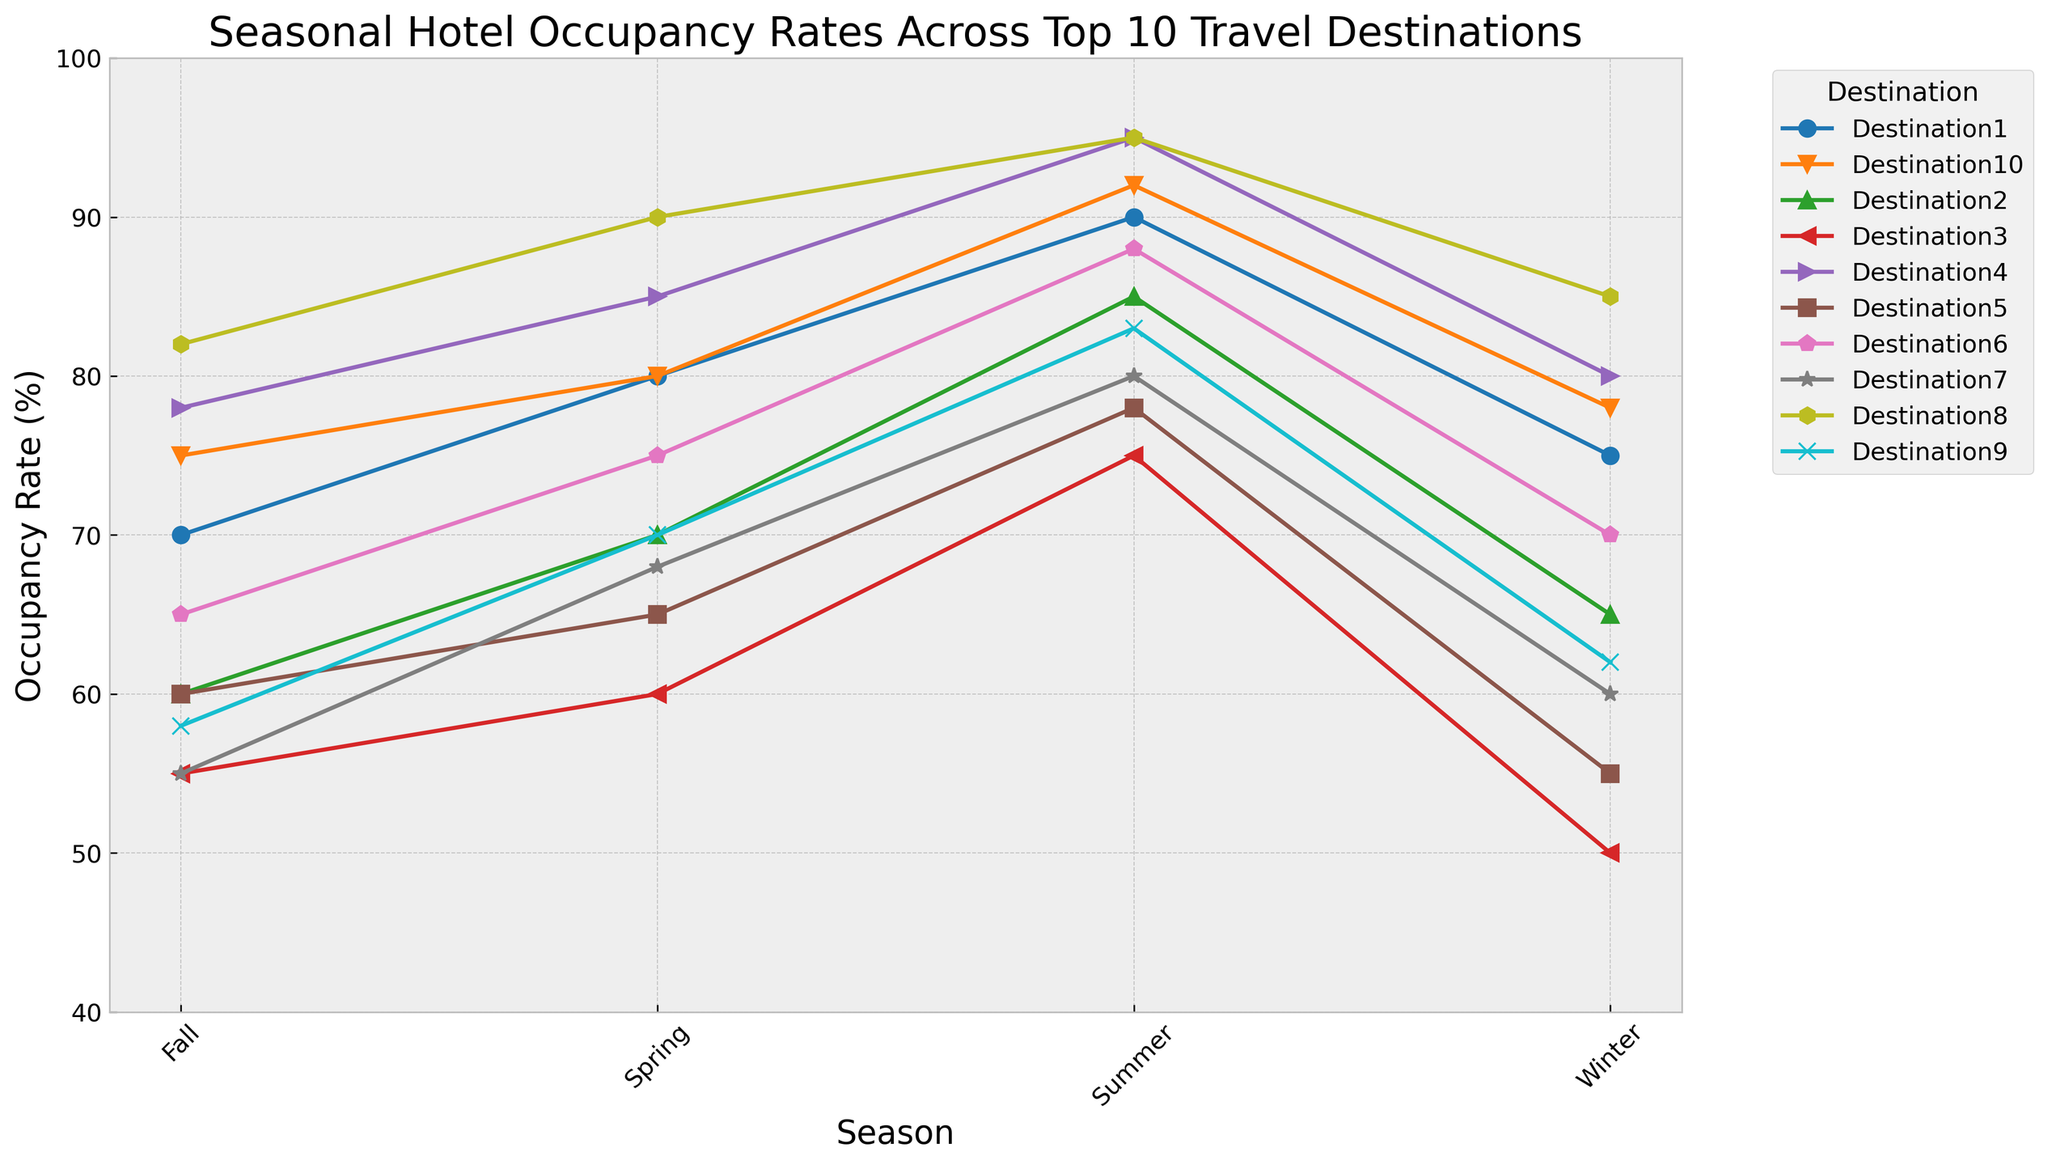Which destination has the highest occupancy rate in Summer? First, identify the occupancy rates for all destinations in Summer from the plot. The highest value is 95%, which belongs to both Destination4 and Destination8. Therefore, both have the highest occupancy rate in Summer.
Answer: Destination4 and Destination8 Which season has the highest average occupancy rate across all destinations? Calculate the average occupancy rate for each season by summing the occupancy rates for all destinations in that season and then dividing by the number of destinations (10). Based on the chart, Summer consistently shows higher rates. Actual averages confirm Summer as the season with the highest average occupancy rate.
Answer: Summer How does the occupancy rate of Destination1 in Spring compare to that in Fall? Compare the heights of the line markers for Destination1 at Spring and Fall. Occupancy rate in Spring is 80% while in Fall it is 70%. Therefore, Spring is higher by 10%.
Answer: Spring is higher by 10% Among all destinations, which has the lowest occupancy rate in Winter? Look at the Winter season markers for all destinations and identify the lowest rate, which is 50% for Destination3.
Answer: Destination3 Which destinations show a decreasing trend in occupancy rate from Spring to Fall? Analyze the slopes of the lines from the Spring marker to the Fall marker for each destination. Destinations that trend downwards during these seasons are Destination2, Destination3, Destination7, and Destination9.
Answer: Destination2, Destination3, Destination7, Destination9 What is the difference in occupancy rates between Winter and Summer for Destination6? The occupancy rate in Winter for Destination6 is 70%, and in Summer, it is 88%. Calculate the difference: 88% - 70% = 18%.
Answer: 18% Which destination shows the most significant increase in occupancy rates from Winter to Summer? Evaluate the change in occupancy rate from Winter to Summer for each destination and find the maximum difference. The largest increase occurs for Destination3, from 50% in Winter to 75% in Summer, a 25% increase.
Answer: Destination3 If the average occupancy rate for Fall is represented in a label, what approximate value would it show? Calculate the Fall average by summing the occupancy rates across all destinations (70, 60, 55, 78, 60, 65, 55, 82, 58, 75 = 658) and then dividing by 10 (number of destinations): 658 / 10 = 65.8%.
Answer: 65.8% Which two destinations have the most similar occupancy rates across all four seasons? By comparing the overall patterns and deviations of the lines for each destination, observe that Destination6 and Destination10 have similar values across the four seasons.
Answer: Destination6 and Destination10 What is the average occupancy rate for Destination8 over all four seasons? Sum the occupancy rates for all seasons for Destination8 (85, 90, 95, 82 = 352) and divide by 4: 352 / 4 = 88%.
Answer: 88% 